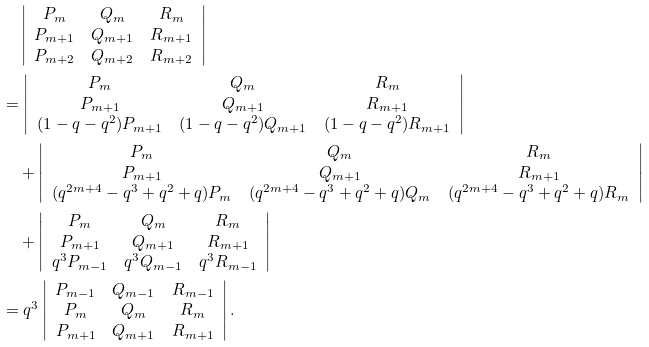Convert formula to latex. <formula><loc_0><loc_0><loc_500><loc_500>& \quad \left | \begin{array} { c c c } P _ { m } & Q _ { m } & R _ { m } \\ P _ { m + 1 } & Q _ { m + 1 } & R _ { m + 1 } \\ P _ { m + 2 } & Q _ { m + 2 } & R _ { m + 2 } \\ \end{array} \right | \\ & = \left | \begin{array} { c c c } P _ { m } & Q _ { m } & R _ { m } \\ P _ { m + 1 } & Q _ { m + 1 } & R _ { m + 1 } \\ ( 1 - q - q ^ { 2 } ) P _ { m + 1 } & ( 1 - q - q ^ { 2 } ) Q _ { m + 1 } & ( 1 - q - q ^ { 2 } ) R _ { m + 1 } \\ \end{array} \right | \\ & \quad + \left | \begin{array} { c c c } P _ { m } & Q _ { m } & R _ { m } \\ P _ { m + 1 } & Q _ { m + 1 } & R _ { m + 1 } \\ ( q ^ { 2 m + 4 } - q ^ { 3 } + q ^ { 2 } + q ) P _ { m } & ( q ^ { 2 m + 4 } - q ^ { 3 } + q ^ { 2 } + q ) Q _ { m } & ( q ^ { 2 m + 4 } - q ^ { 3 } + q ^ { 2 } + q ) R _ { m } \\ \end{array} \right | \\ & \quad + \left | \begin{array} { c c c } P _ { m } & Q _ { m } & R _ { m } \\ P _ { m + 1 } & Q _ { m + 1 } & R _ { m + 1 } \\ q ^ { 3 } P _ { m - 1 } & q ^ { 3 } Q _ { m - 1 } & q ^ { 3 } R _ { m - 1 } \\ \end{array} \right | \\ & = q ^ { 3 } \left | \begin{array} { c c c } P _ { m - 1 } & Q _ { m - 1 } & R _ { m - 1 } \\ P _ { m } & Q _ { m } & R _ { m } \\ P _ { m + 1 } & Q _ { m + 1 } & R _ { m + 1 } \\ \end{array} \right | .</formula> 